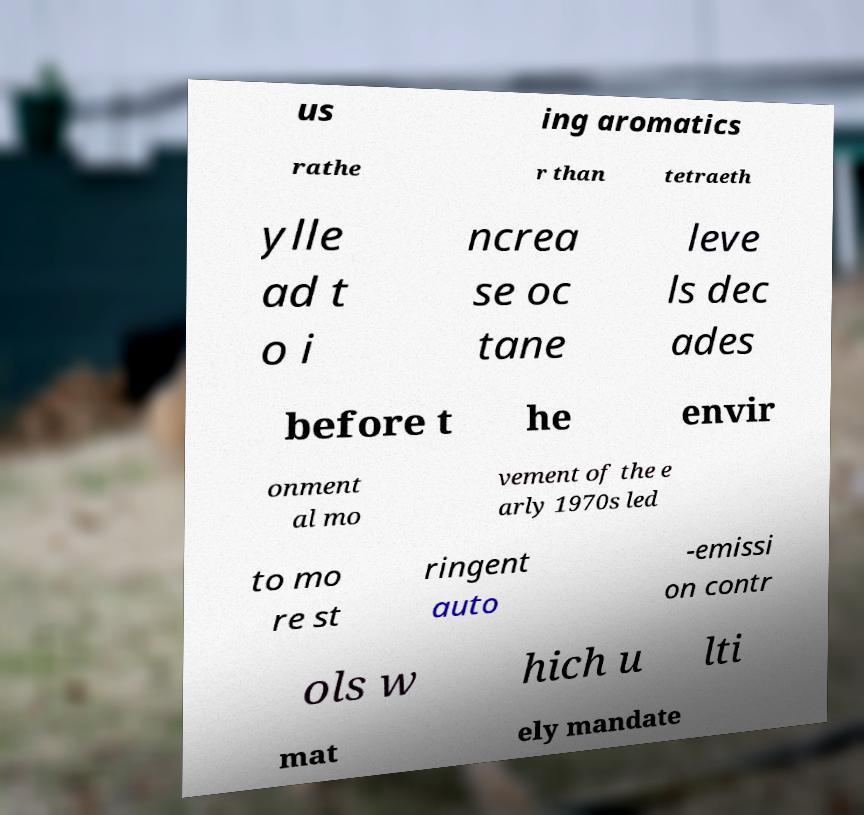Please read and relay the text visible in this image. What does it say? us ing aromatics rathe r than tetraeth ylle ad t o i ncrea se oc tane leve ls dec ades before t he envir onment al mo vement of the e arly 1970s led to mo re st ringent auto -emissi on contr ols w hich u lti mat ely mandate 